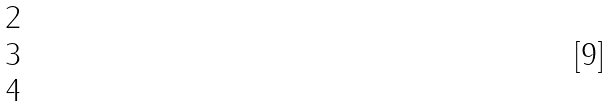<formula> <loc_0><loc_0><loc_500><loc_500>\begin{matrix} 2 \\ 3 \\ 4 \end{matrix}</formula> 